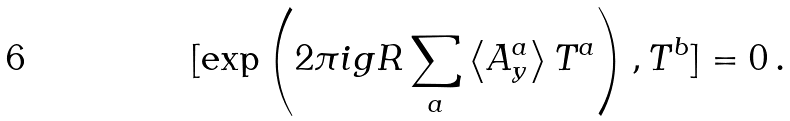<formula> <loc_0><loc_0><loc_500><loc_500>[ \exp \left ( 2 \pi i g R \sum _ { a } \left < A ^ { a } _ { y } \right > T ^ { a } \right ) , T ^ { b } ] = 0 \, .</formula> 